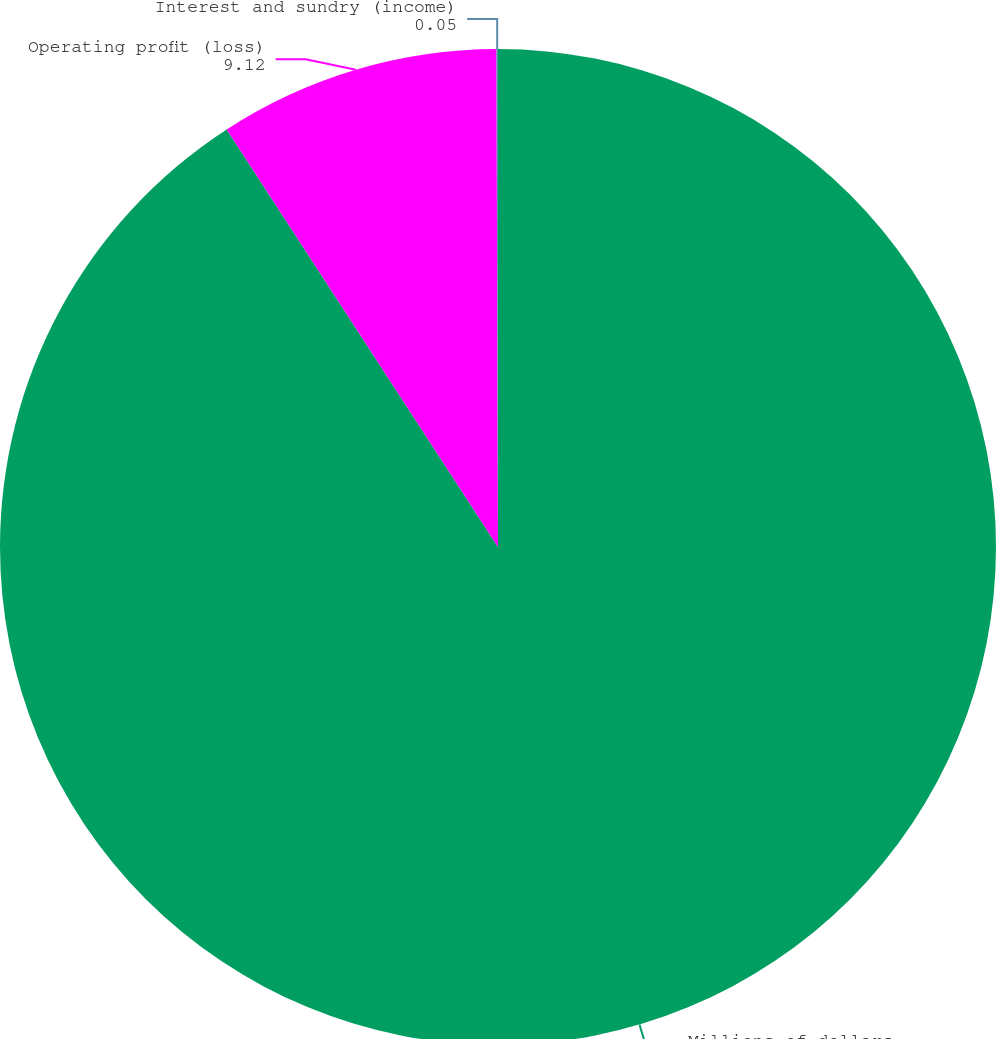<chart> <loc_0><loc_0><loc_500><loc_500><pie_chart><fcel>Millions of dollars<fcel>Operating profit (loss)<fcel>Interest and sundry (income)<nl><fcel>90.83%<fcel>9.12%<fcel>0.05%<nl></chart> 